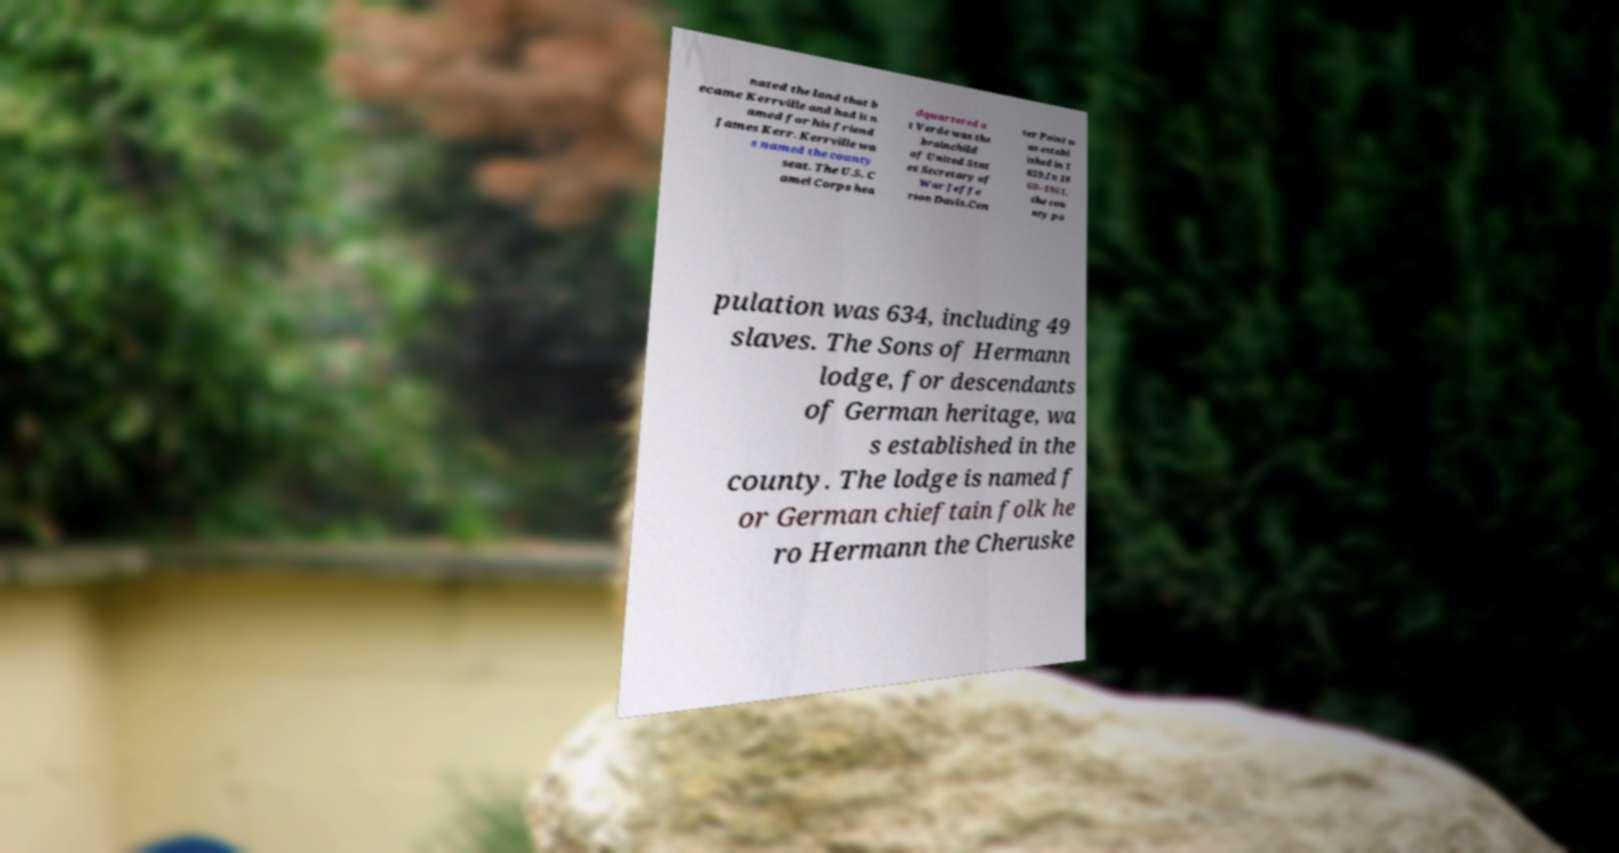Can you accurately transcribe the text from the provided image for me? nated the land that b ecame Kerrville and had it n amed for his friend James Kerr. Kerrville wa s named the county seat. The U.S. C amel Corps hea dquartered a t Verde was the brainchild of United Stat es Secretary of War Jeffe rson Davis.Cen ter Point w as establ ished in 1 859.In 18 60–1861, the cou nty po pulation was 634, including 49 slaves. The Sons of Hermann lodge, for descendants of German heritage, wa s established in the county. The lodge is named f or German chieftain folk he ro Hermann the Cheruske 